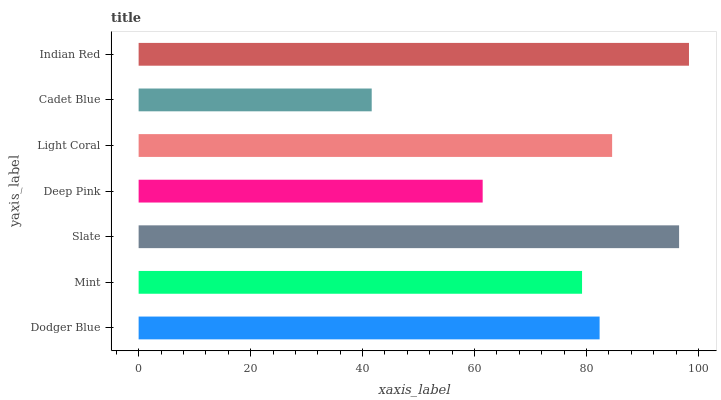Is Cadet Blue the minimum?
Answer yes or no. Yes. Is Indian Red the maximum?
Answer yes or no. Yes. Is Mint the minimum?
Answer yes or no. No. Is Mint the maximum?
Answer yes or no. No. Is Dodger Blue greater than Mint?
Answer yes or no. Yes. Is Mint less than Dodger Blue?
Answer yes or no. Yes. Is Mint greater than Dodger Blue?
Answer yes or no. No. Is Dodger Blue less than Mint?
Answer yes or no. No. Is Dodger Blue the high median?
Answer yes or no. Yes. Is Dodger Blue the low median?
Answer yes or no. Yes. Is Cadet Blue the high median?
Answer yes or no. No. Is Light Coral the low median?
Answer yes or no. No. 